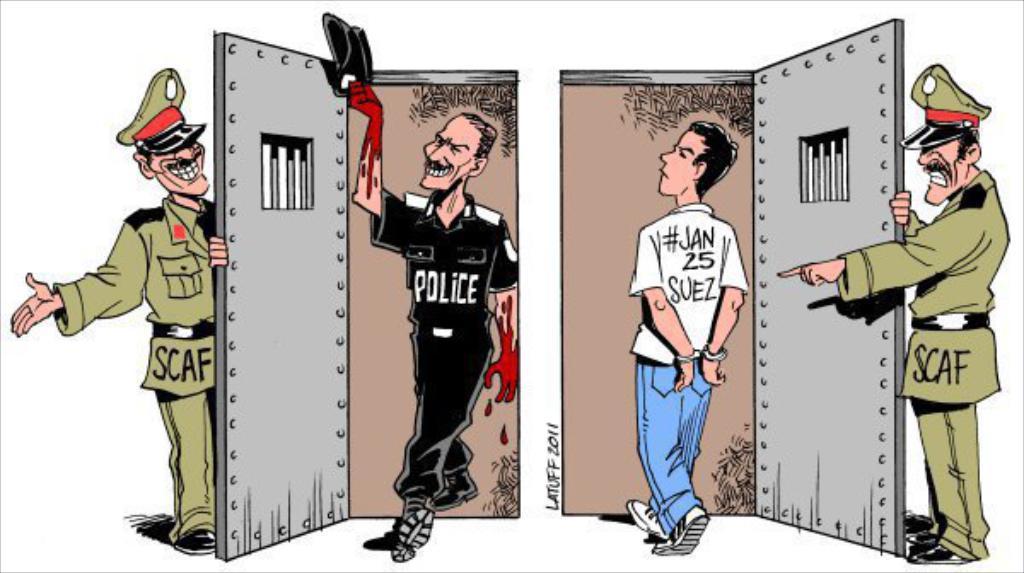In one or two sentences, can you explain what this image depicts? In this image we can see cartoon pictures of man in different costumes. 